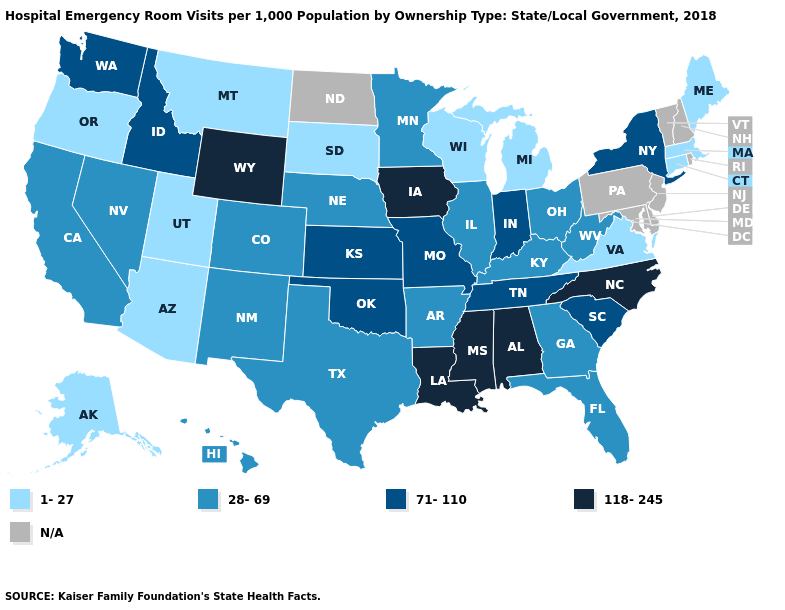Name the states that have a value in the range 71-110?
Quick response, please. Idaho, Indiana, Kansas, Missouri, New York, Oklahoma, South Carolina, Tennessee, Washington. Among the states that border Wisconsin , does Iowa have the highest value?
Quick response, please. Yes. Does Georgia have the lowest value in the USA?
Give a very brief answer. No. Name the states that have a value in the range 28-69?
Quick response, please. Arkansas, California, Colorado, Florida, Georgia, Hawaii, Illinois, Kentucky, Minnesota, Nebraska, Nevada, New Mexico, Ohio, Texas, West Virginia. What is the value of Delaware?
Keep it brief. N/A. Is the legend a continuous bar?
Be succinct. No. What is the value of South Dakota?
Quick response, please. 1-27. What is the value of Indiana?
Concise answer only. 71-110. What is the lowest value in states that border Vermont?
Answer briefly. 1-27. Name the states that have a value in the range 118-245?
Write a very short answer. Alabama, Iowa, Louisiana, Mississippi, North Carolina, Wyoming. What is the highest value in states that border Iowa?
Be succinct. 71-110. Does the first symbol in the legend represent the smallest category?
Be succinct. Yes. What is the highest value in the Northeast ?
Short answer required. 71-110. What is the value of Idaho?
Answer briefly. 71-110. What is the lowest value in the USA?
Quick response, please. 1-27. 